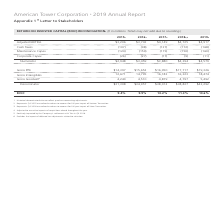According to American Tower Corporation's financial document, What does Gross Goodwill exclude? the impact of deferred tax adjustments related to valuation. The document states: "6 Excludes the impact of deferred tax adjustments related to valuation...." Also, What was the ROIC in 2015? According to the financial document, 9.4%. The relevant text states: "9.4%..." Also, What was the gross PPE in 2016? According to the financial document, $15,652 (in millions). The relevant text states: "$15,652..." Also, can you calculate: What was the change in adjusted EBITDA between 2016 and 2017? Based on the calculation: $4,149-$3,743, the result is 406 (in millions). This is based on the information: "$3,743 $4,149..." The key data points involved are: 3,743, 4,149. Also, How many years did gross intangibles exceed $15,000 million? Counting the relevant items in the document: 2017, 2018, 2019, I find 3 instances. The key data points involved are: 2017, 2018, 2019. Also, can you calculate: What was the percentage change in gross goodwill between 2018 and 2019? To answer this question, I need to perform calculations using the financial data. The calculation is: (5,492-4,797)/4,797, which equals 14.49 (percentage). This is based on the information: "4,797 5,492..." The key data points involved are: 4,797, 5,492. 